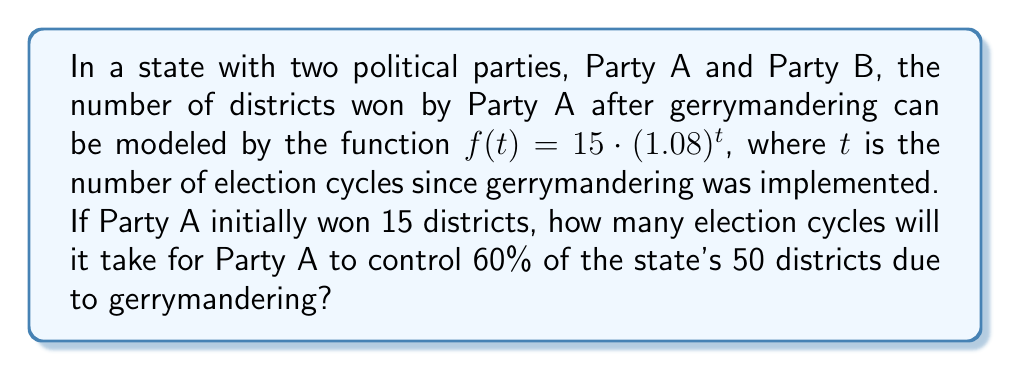Show me your answer to this math problem. Let's approach this step-by-step:

1) We're given the function $f(t) = 15 \cdot (1.08)^t$, where $f(t)$ represents the number of districts won by Party A after $t$ election cycles.

2) We need to find when Party A controls 60% of 50 districts. That's:
   $60\% \text{ of } 50 = 0.6 \cdot 50 = 30$ districts

3) So, we need to solve the equation:
   $15 \cdot (1.08)^t = 30$

4) Dividing both sides by 15:
   $(1.08)^t = 2$

5) Taking the natural log of both sides:
   $t \cdot \ln(1.08) = \ln(2)$

6) Solving for $t$:
   $t = \frac{\ln(2)}{\ln(1.08)}$

7) Using a calculator:
   $t \approx 9.006$

8) Since we can't have a fractional number of election cycles, we need to round up to the next whole number.
Answer: 10 election cycles 